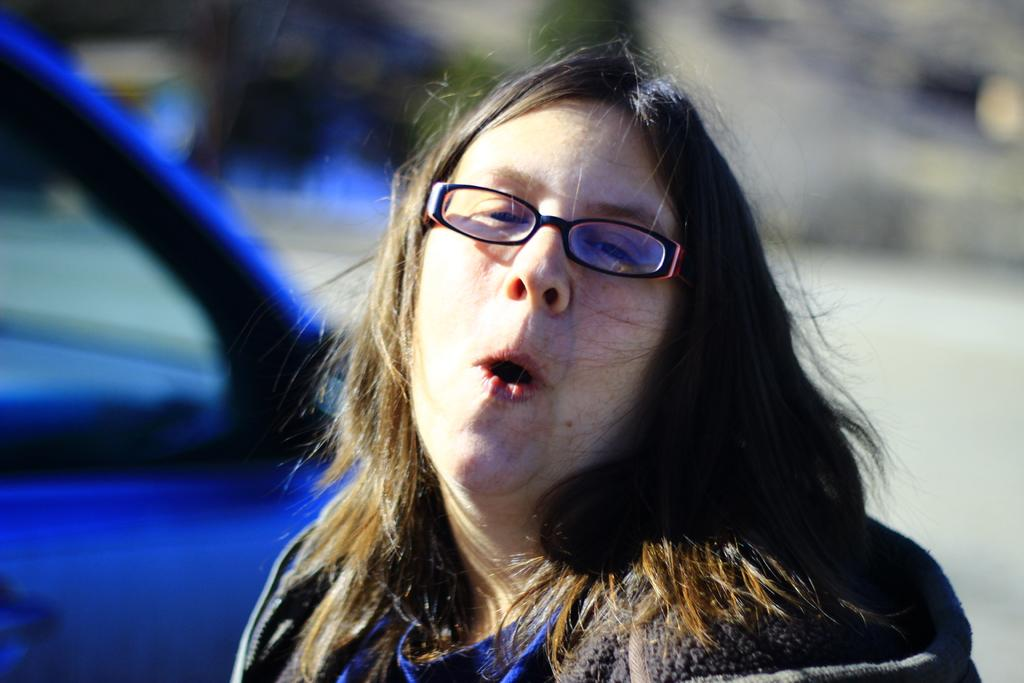What is the main subject in the image? There is a lady standing in the image. Can you describe the background of the image? The background of the image is blurred. How many geese are flying in the background of the image? There are no geese visible in the background of the image. What type of lead is being used by the lady in the image? There is no lead present in the image, and the lady is not using any lead. 